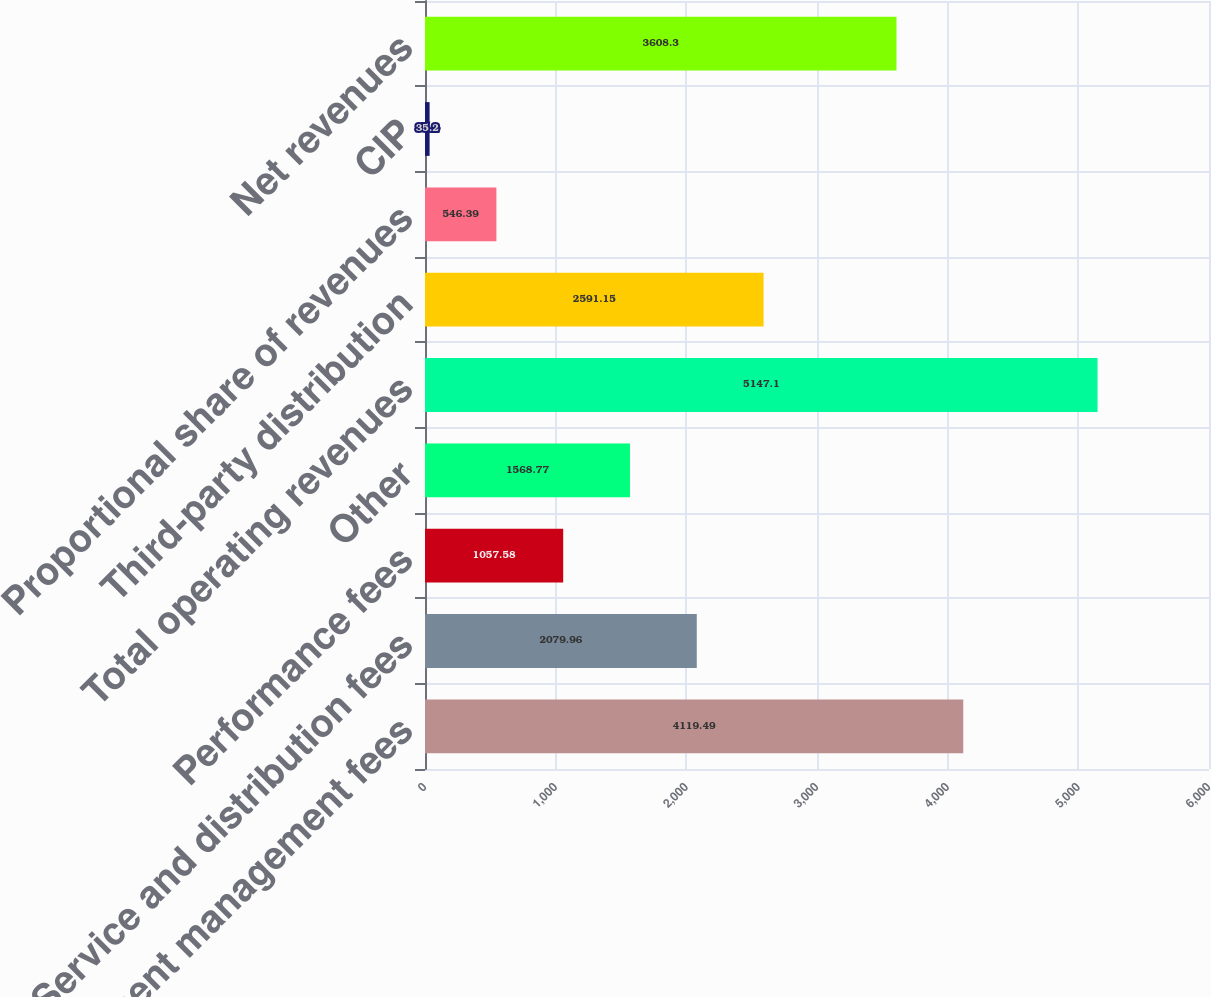Convert chart to OTSL. <chart><loc_0><loc_0><loc_500><loc_500><bar_chart><fcel>Investment management fees<fcel>Service and distribution fees<fcel>Performance fees<fcel>Other<fcel>Total operating revenues<fcel>Third-party distribution<fcel>Proportional share of revenues<fcel>CIP<fcel>Net revenues<nl><fcel>4119.49<fcel>2079.96<fcel>1057.58<fcel>1568.77<fcel>5147.1<fcel>2591.15<fcel>546.39<fcel>35.2<fcel>3608.3<nl></chart> 